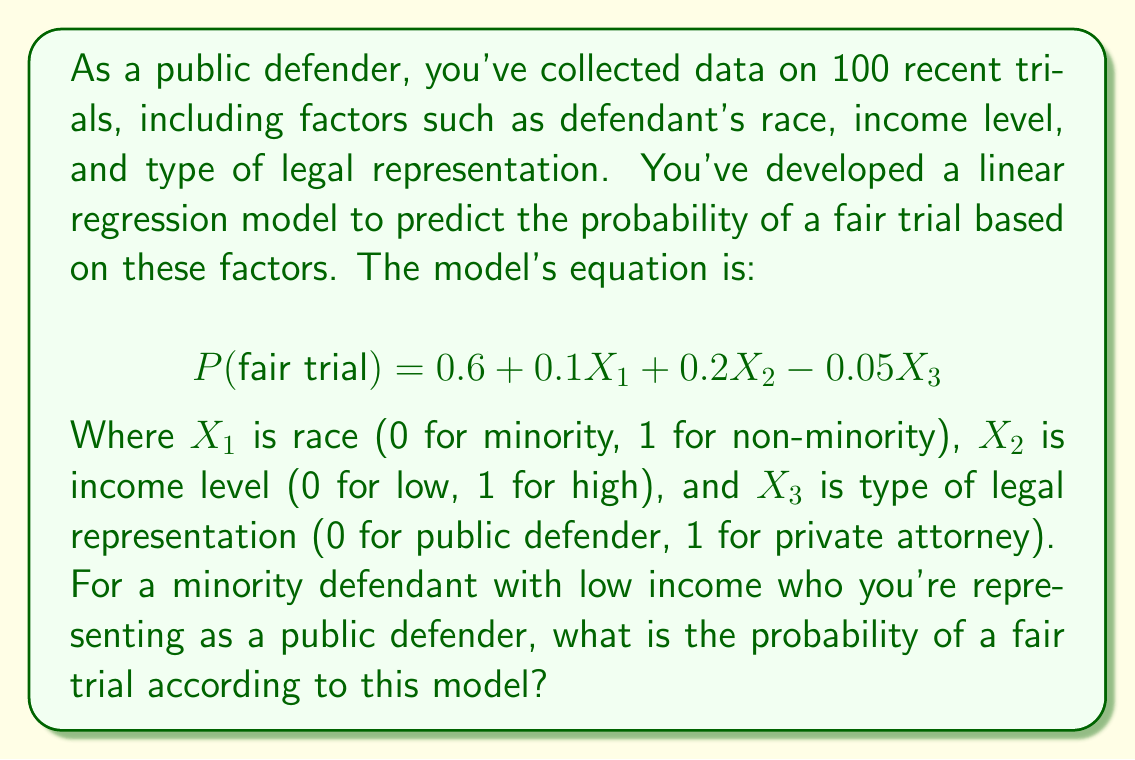Solve this math problem. To solve this problem, we need to substitute the appropriate values into the linear regression equation:

1) First, let's identify the values for each variable:
   $X_1$ (race) = 0 (minority)
   $X_2$ (income level) = 0 (low income)
   $X_3$ (legal representation) = 0 (public defender)

2) Now, let's substitute these values into the equation:

   $$ P(\text{fair trial}) = 0.6 + 0.1X_1 + 0.2X_2 - 0.05X_3 $$
   $$ P(\text{fair trial}) = 0.6 + 0.1(0) + 0.2(0) - 0.05(0) $$

3) Simplify:
   $$ P(\text{fair trial}) = 0.6 + 0 + 0 - 0 = 0.6 $$

4) Therefore, according to this model, the probability of a fair trial for this defendant is 0.6 or 60%.

It's important to note that this result highlights potential systemic biases in the justice system, as the model suggests that being a minority and having low income negatively impacts the probability of a fair trial. As a public defender committed to equal access to justice, this information could be crucial in advocating for systemic changes.
Answer: 0.6 or 60% 